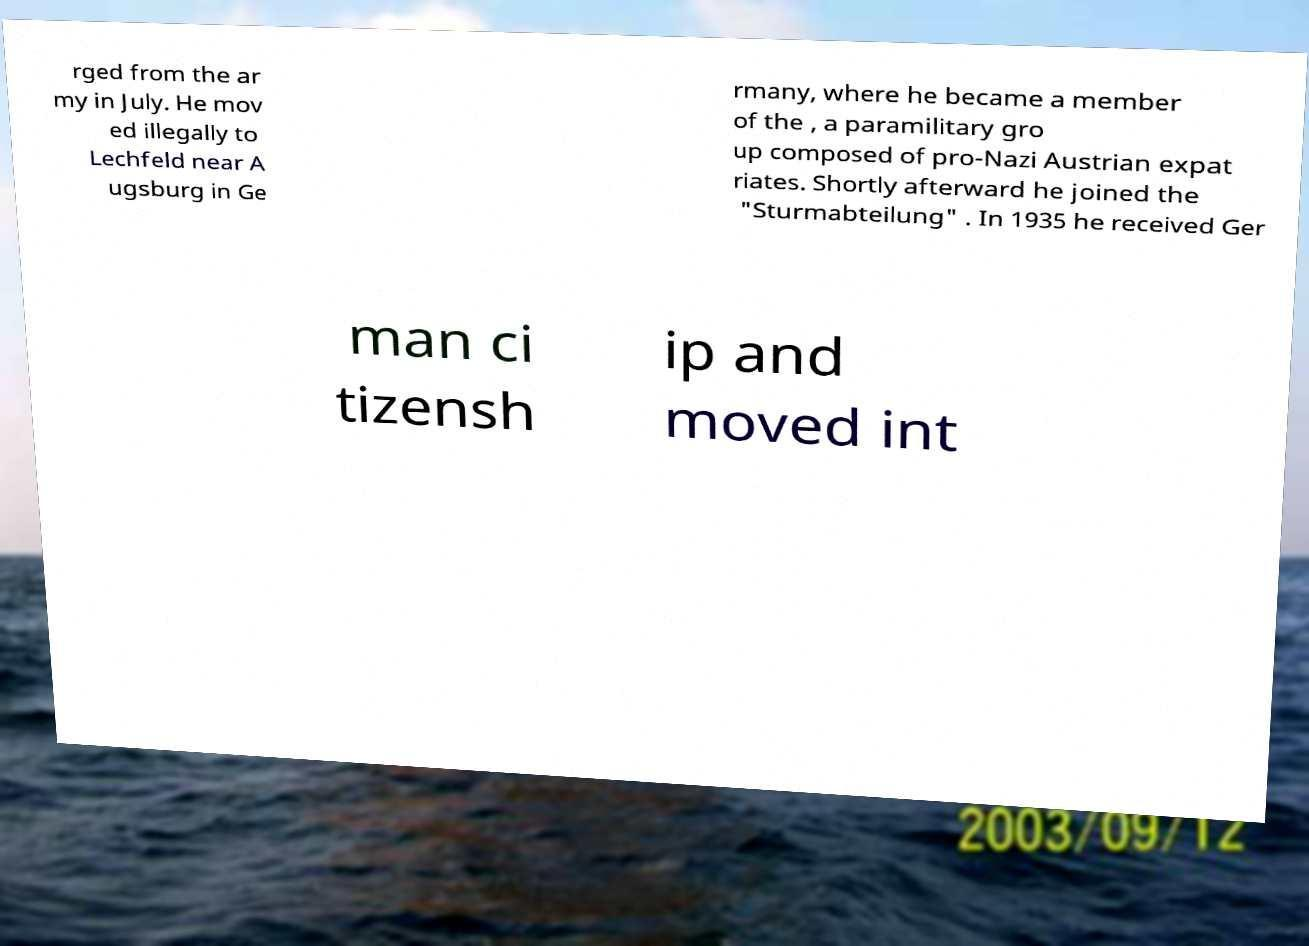For documentation purposes, I need the text within this image transcribed. Could you provide that? rged from the ar my in July. He mov ed illegally to Lechfeld near A ugsburg in Ge rmany, where he became a member of the , a paramilitary gro up composed of pro-Nazi Austrian expat riates. Shortly afterward he joined the "Sturmabteilung" . In 1935 he received Ger man ci tizensh ip and moved int 